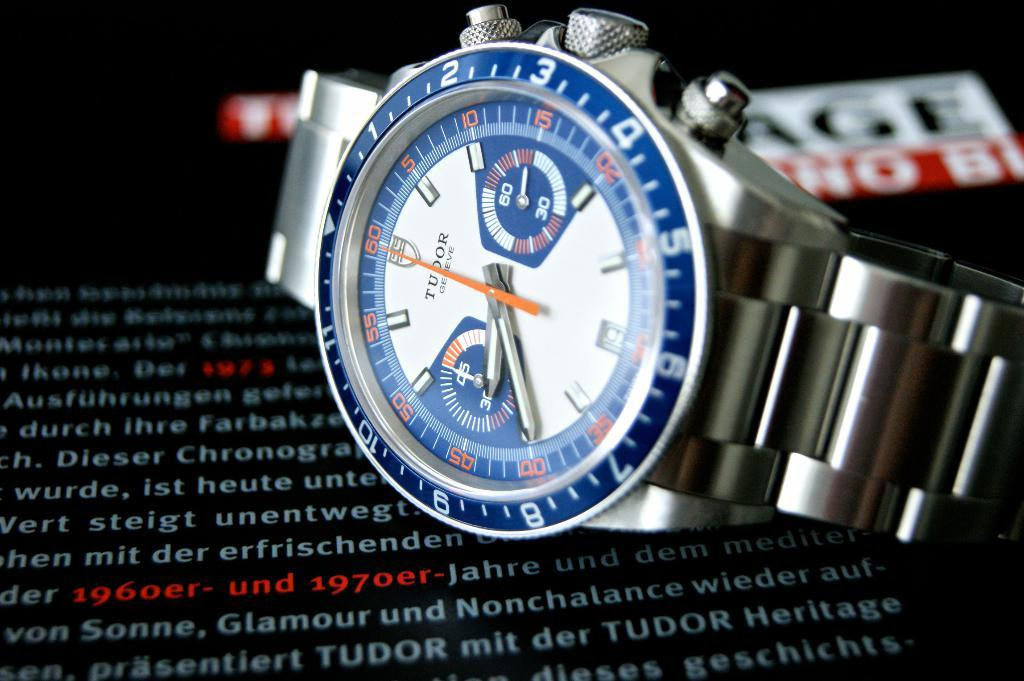<image>
Write a terse but informative summary of the picture. A Tudor watch with orange numbers in a blue rim lays on its side. 